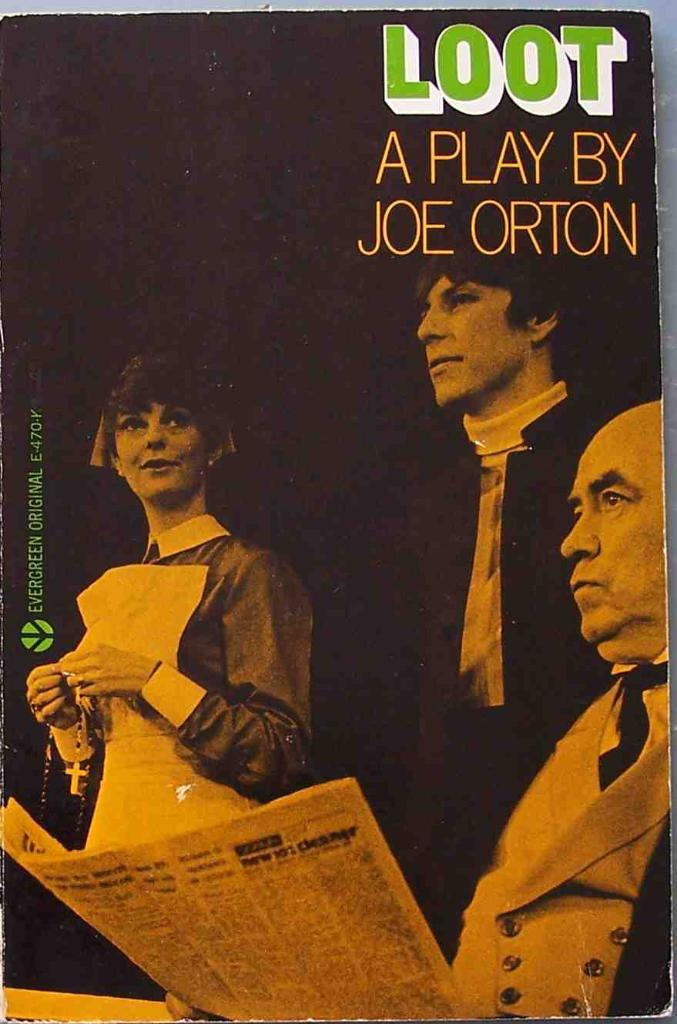<image>
Create a compact narrative representing the image presented. A poster advertises a play by Joe Orton called Loot. 